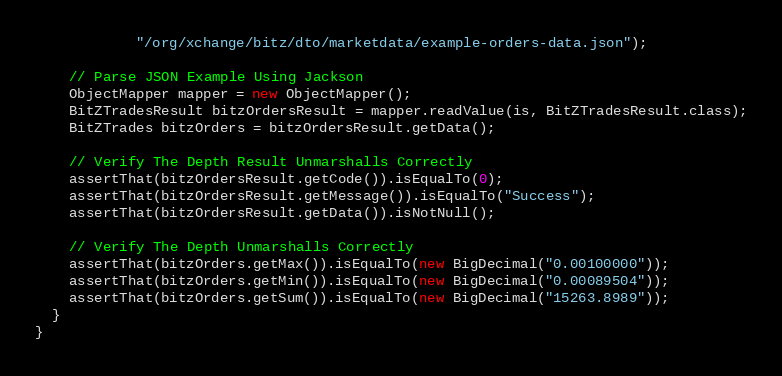<code> <loc_0><loc_0><loc_500><loc_500><_Java_>            "/org/xchange/bitz/dto/marketdata/example-orders-data.json");

    // Parse JSON Example Using Jackson
    ObjectMapper mapper = new ObjectMapper();
    BitZTradesResult bitzOrdersResult = mapper.readValue(is, BitZTradesResult.class);
    BitZTrades bitzOrders = bitzOrdersResult.getData();

    // Verify The Depth Result Unmarshalls Correctly
    assertThat(bitzOrdersResult.getCode()).isEqualTo(0);
    assertThat(bitzOrdersResult.getMessage()).isEqualTo("Success");
    assertThat(bitzOrdersResult.getData()).isNotNull();

    // Verify The Depth Unmarshalls Correctly
    assertThat(bitzOrders.getMax()).isEqualTo(new BigDecimal("0.00100000"));
    assertThat(bitzOrders.getMin()).isEqualTo(new BigDecimal("0.00089504"));
    assertThat(bitzOrders.getSum()).isEqualTo(new BigDecimal("15263.8989"));
  }
}
</code> 